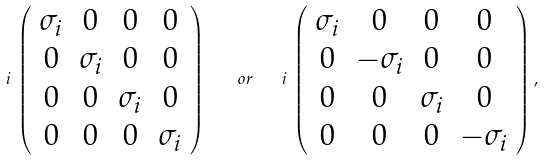<formula> <loc_0><loc_0><loc_500><loc_500>i \, \left ( \begin{array} { c c c c } { { \sigma _ { i } } } & { 0 } & { 0 } & { 0 } \\ { { 0 } } & { { \sigma _ { i } } } & { 0 } & { 0 } \\ { { 0 } } & { 0 } & { { \sigma _ { i } } } & { 0 } \\ { { 0 } } & { 0 } & { 0 } & { { \sigma _ { i } } } \end{array} \right ) \quad o r \quad i \, \left ( \begin{array} { c c c c } { { \sigma _ { i } } } & { 0 } & { 0 } & { 0 } \\ { { 0 } } & { { - \sigma _ { i } } } & { 0 } & { 0 } \\ { { 0 } } & { 0 } & { { \sigma _ { i } } } & { 0 } \\ { { 0 } } & { 0 } & { 0 } & { { - \sigma _ { i } } } \end{array} \right ) ,</formula> 